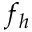Convert formula to latex. <formula><loc_0><loc_0><loc_500><loc_500>f _ { h }</formula> 